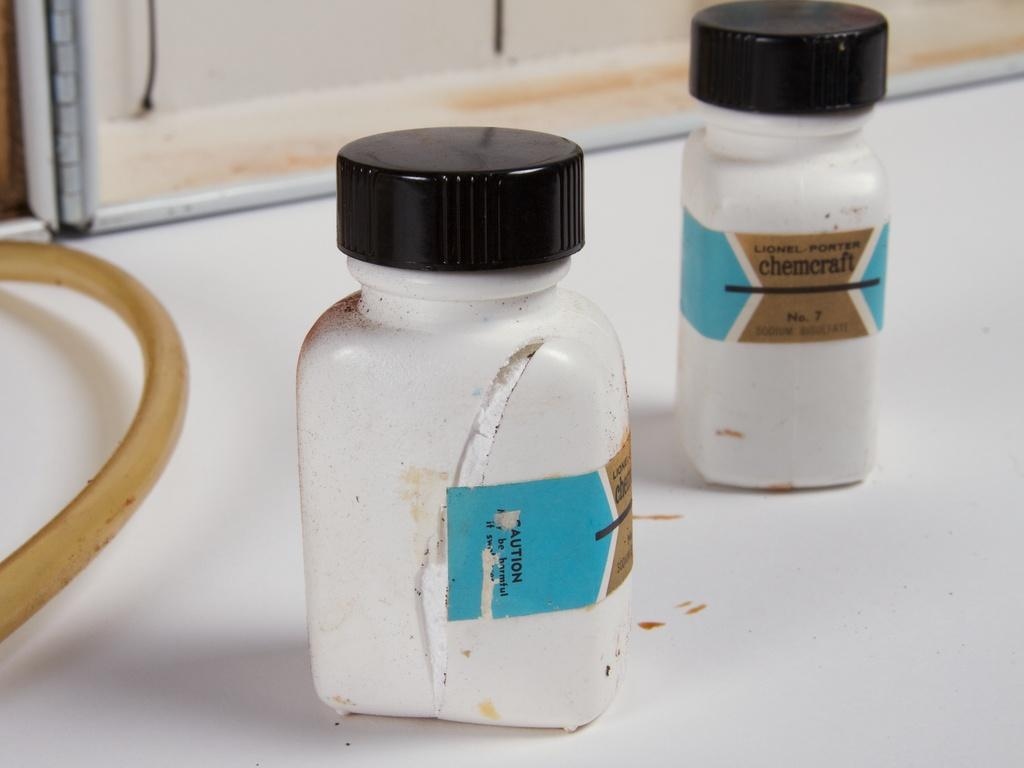How many bottles are visible in the image? There are two bottles in the image. What can be observed about the caps of the bottles? The caps of the bottles have a black color. How many ducks are swimming in the frame of the image? There are no ducks present in the image. In which direction are the bottles facing in the image? The provided facts do not mention the direction the bottles are facing, so it cannot be determined from the image. 